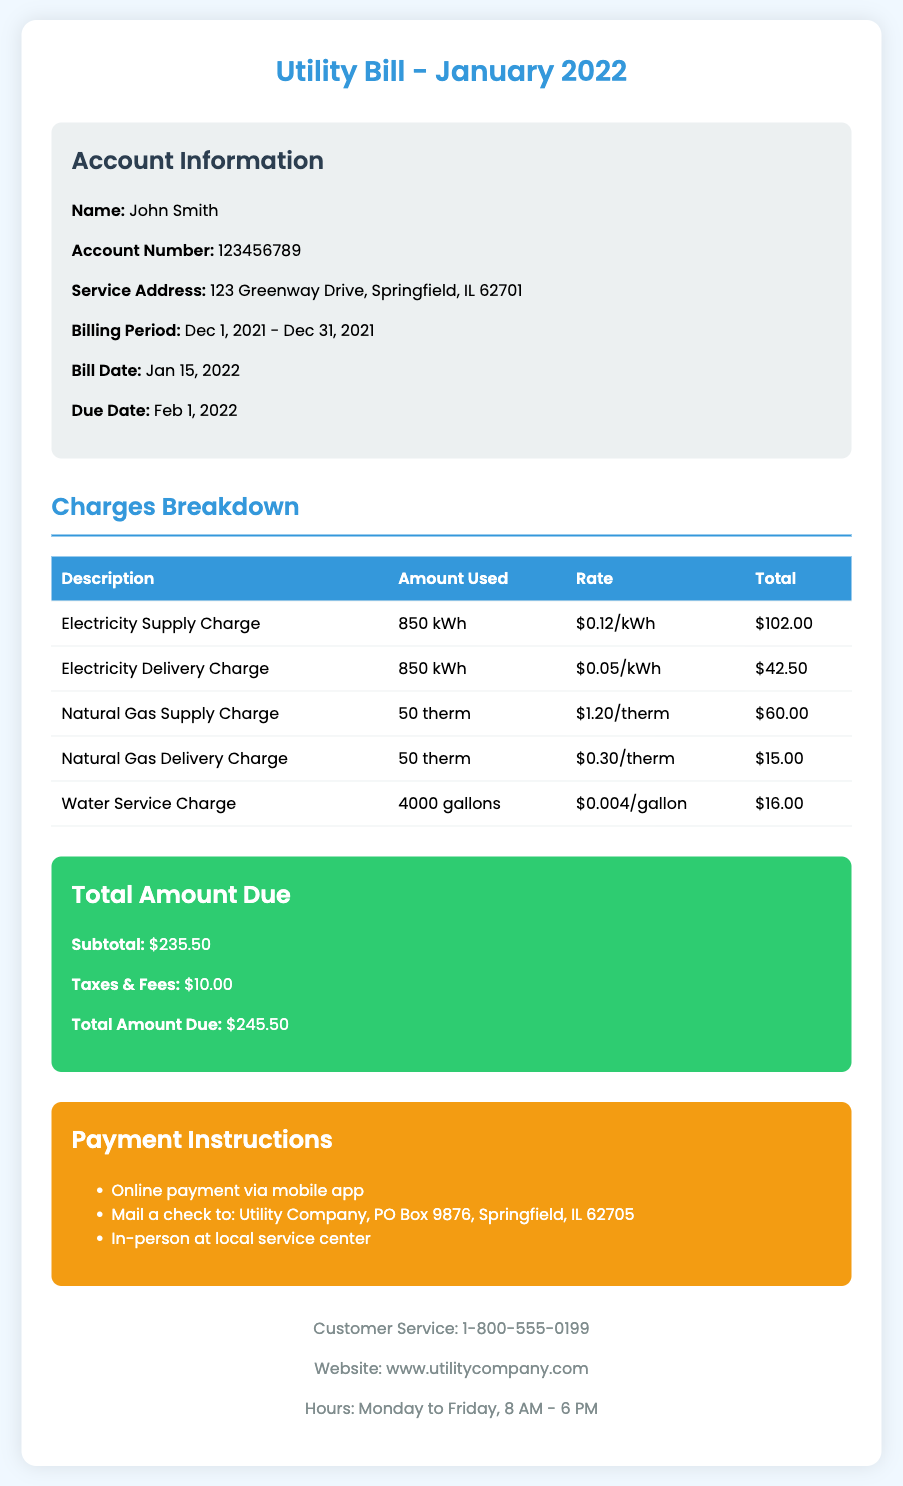what is the billing period? The billing period indicates the time frame covered by the bill, which is from December 1, 2021 to December 31, 2021.
Answer: Dec 1, 2021 - Dec 31, 2021 who is the account holder? The account holder's name is specified at the beginning of the account information section.
Answer: John Smith what is the total amount due? The total amount due is calculated at the end of the charges breakdown section, summarizing costs including taxes and fees.
Answer: $245.50 how much was charged for electricity supply? The electricity supply charge is listed as a specific amount in the charges breakdown table.
Answer: $102.00 how many gallons of water were used? The amount of water used is detailed in the charges breakdown, which shows the usage measurement.
Answer: 4000 gallons what is the due date for the payment? The due date for payment is provided in the account information section of the bill document.
Answer: Feb 1, 2022 what is the rate for natural gas supply? The rate for natural gas supply is clearly stated in the charges breakdown section, indicating the cost per unit.
Answer: $1.20/therm how can payments be made? Payment instructions provide options for settling the bill and are listed in a clear format within the document.
Answer: Online payment via mobile app, mail a check, in-person at local service center how much was charged for taxes and fees? The charges section includes a specific line for taxes and fees which contributes to the total amount due.
Answer: $10.00 